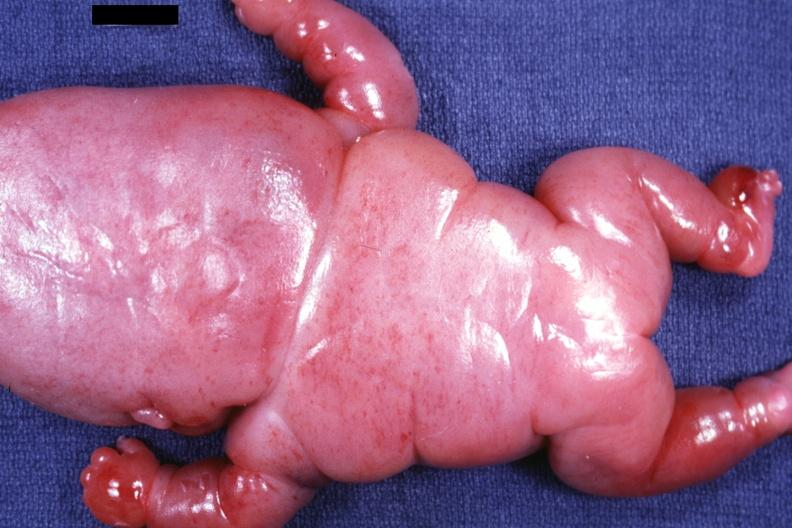what is present?
Answer the question using a single word or phrase. Lymphangiomatosis 